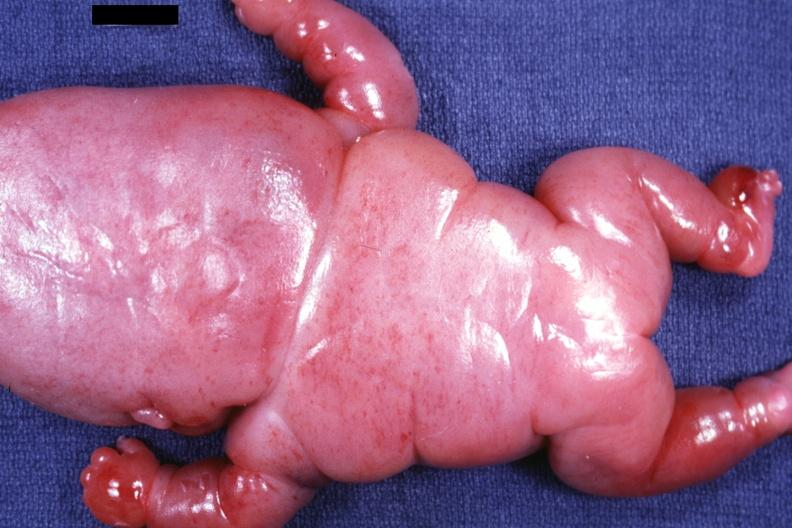what is present?
Answer the question using a single word or phrase. Lymphangiomatosis 